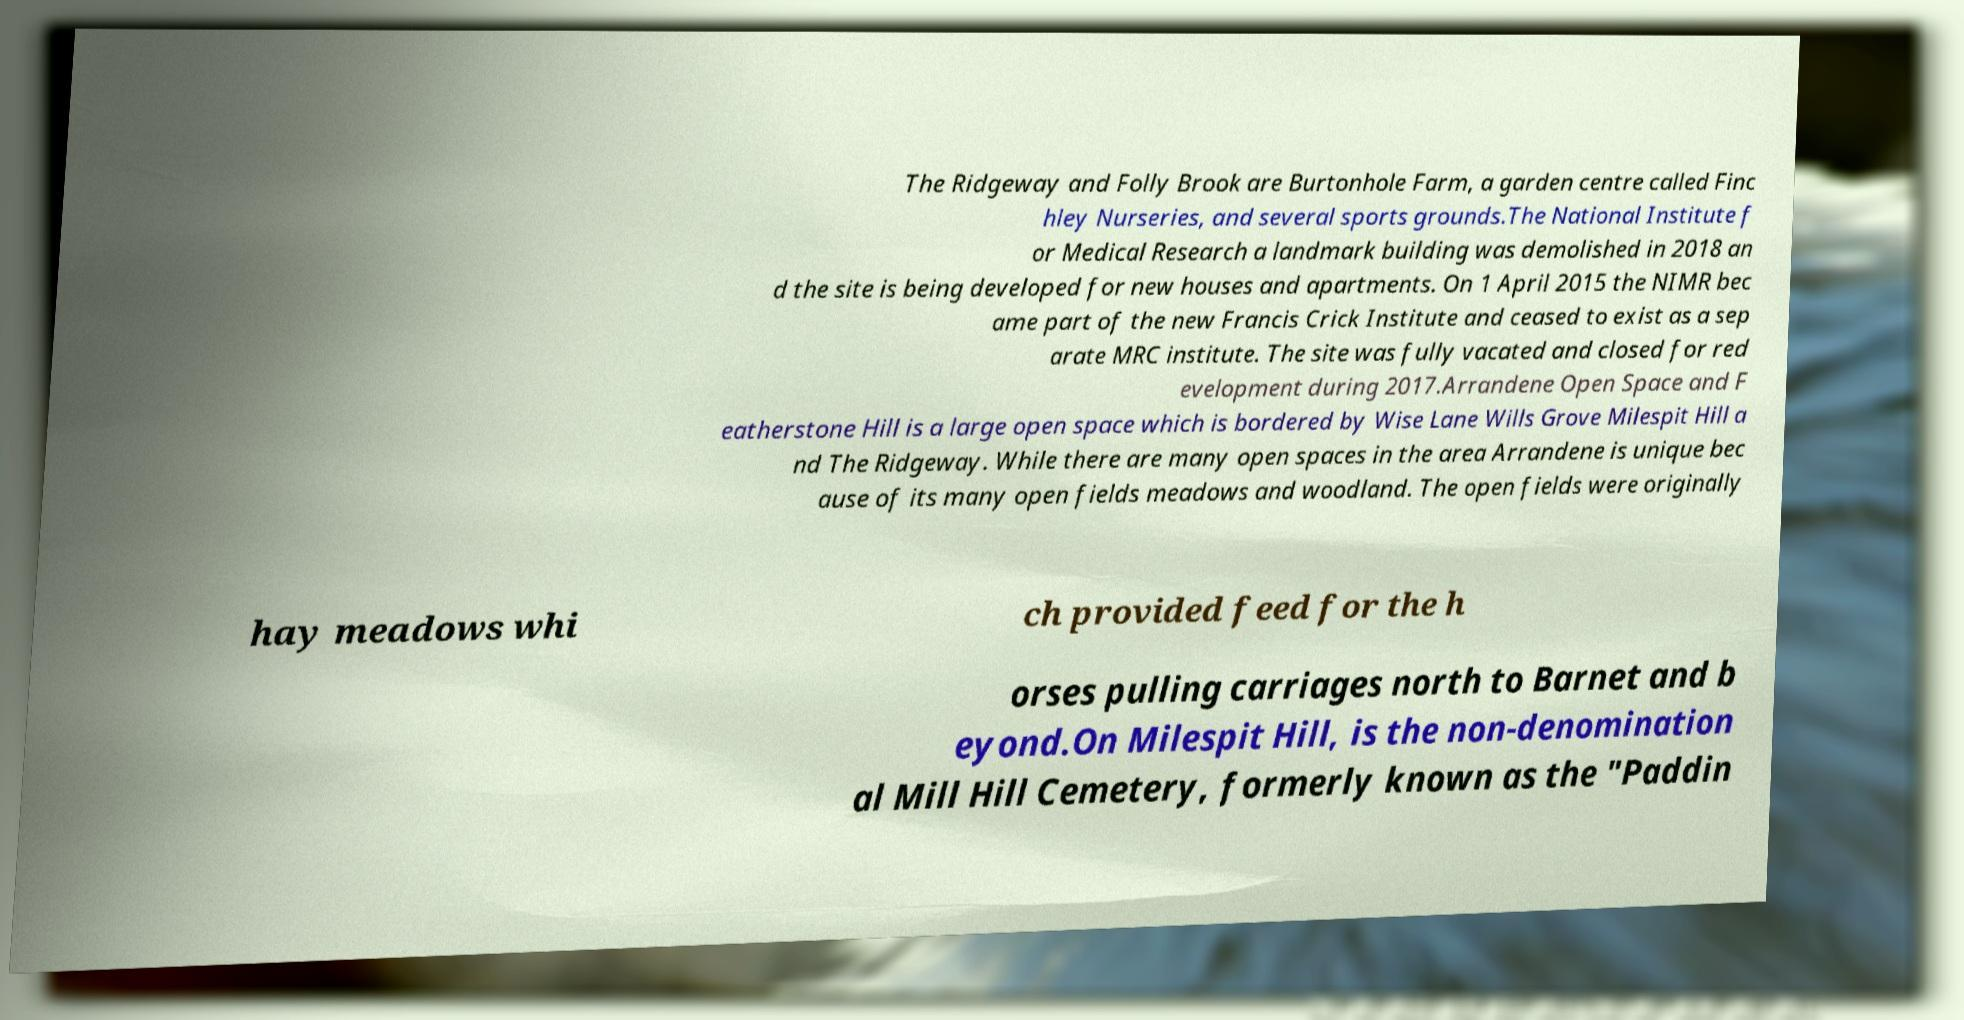Could you extract and type out the text from this image? The Ridgeway and Folly Brook are Burtonhole Farm, a garden centre called Finc hley Nurseries, and several sports grounds.The National Institute f or Medical Research a landmark building was demolished in 2018 an d the site is being developed for new houses and apartments. On 1 April 2015 the NIMR bec ame part of the new Francis Crick Institute and ceased to exist as a sep arate MRC institute. The site was fully vacated and closed for red evelopment during 2017.Arrandene Open Space and F eatherstone Hill is a large open space which is bordered by Wise Lane Wills Grove Milespit Hill a nd The Ridgeway. While there are many open spaces in the area Arrandene is unique bec ause of its many open fields meadows and woodland. The open fields were originally hay meadows whi ch provided feed for the h orses pulling carriages north to Barnet and b eyond.On Milespit Hill, is the non-denomination al Mill Hill Cemetery, formerly known as the "Paddin 